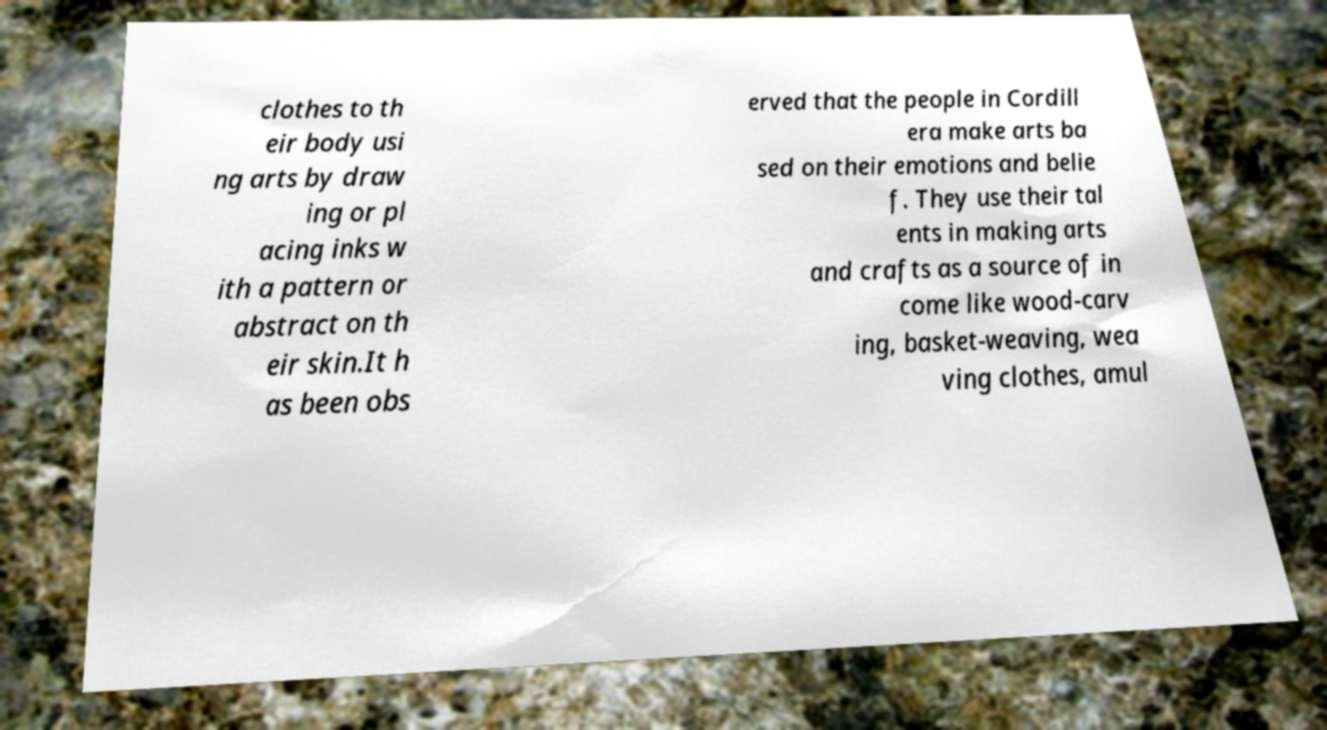For documentation purposes, I need the text within this image transcribed. Could you provide that? clothes to th eir body usi ng arts by draw ing or pl acing inks w ith a pattern or abstract on th eir skin.It h as been obs erved that the people in Cordill era make arts ba sed on their emotions and belie f. They use their tal ents in making arts and crafts as a source of in come like wood-carv ing, basket-weaving, wea ving clothes, amul 